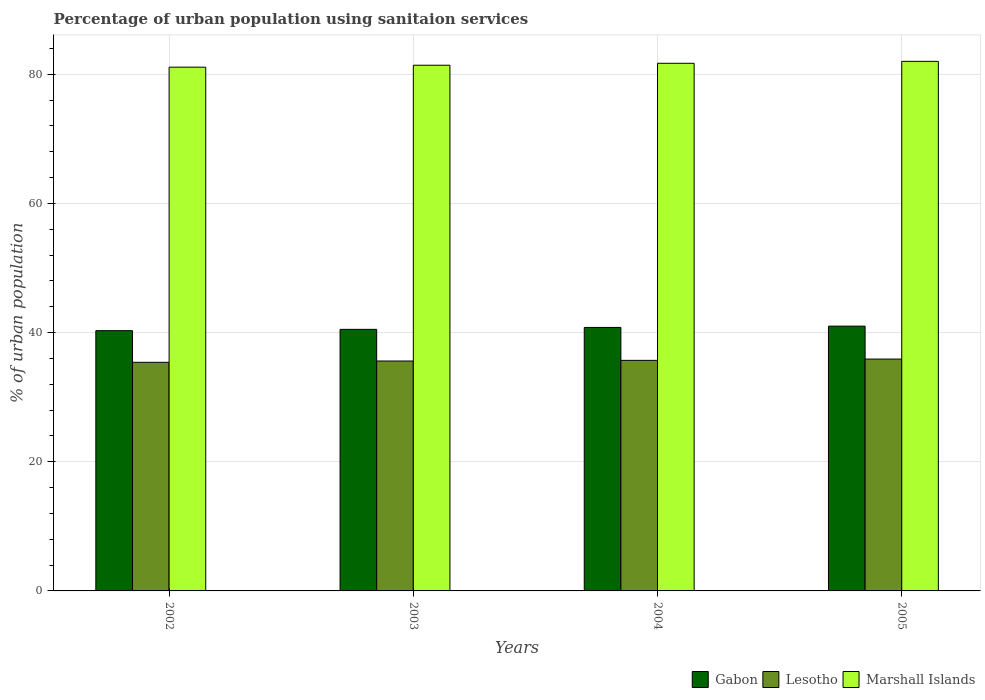How many different coloured bars are there?
Provide a short and direct response. 3. How many groups of bars are there?
Keep it short and to the point. 4. Are the number of bars per tick equal to the number of legend labels?
Your answer should be compact. Yes. Are the number of bars on each tick of the X-axis equal?
Provide a succinct answer. Yes. How many bars are there on the 4th tick from the left?
Ensure brevity in your answer.  3. What is the label of the 1st group of bars from the left?
Your response must be concise. 2002. In how many cases, is the number of bars for a given year not equal to the number of legend labels?
Your response must be concise. 0. What is the percentage of urban population using sanitaion services in Lesotho in 2005?
Make the answer very short. 35.9. Across all years, what is the maximum percentage of urban population using sanitaion services in Lesotho?
Provide a succinct answer. 35.9. Across all years, what is the minimum percentage of urban population using sanitaion services in Gabon?
Give a very brief answer. 40.3. In which year was the percentage of urban population using sanitaion services in Gabon maximum?
Keep it short and to the point. 2005. In which year was the percentage of urban population using sanitaion services in Gabon minimum?
Your response must be concise. 2002. What is the total percentage of urban population using sanitaion services in Gabon in the graph?
Give a very brief answer. 162.6. What is the difference between the percentage of urban population using sanitaion services in Lesotho in 2003 and that in 2004?
Your response must be concise. -0.1. What is the difference between the percentage of urban population using sanitaion services in Gabon in 2005 and the percentage of urban population using sanitaion services in Lesotho in 2003?
Provide a short and direct response. 5.4. What is the average percentage of urban population using sanitaion services in Marshall Islands per year?
Your response must be concise. 81.55. In the year 2002, what is the difference between the percentage of urban population using sanitaion services in Marshall Islands and percentage of urban population using sanitaion services in Lesotho?
Offer a terse response. 45.7. What is the ratio of the percentage of urban population using sanitaion services in Gabon in 2002 to that in 2005?
Make the answer very short. 0.98. Is the percentage of urban population using sanitaion services in Marshall Islands in 2002 less than that in 2004?
Provide a short and direct response. Yes. Is the difference between the percentage of urban population using sanitaion services in Marshall Islands in 2003 and 2005 greater than the difference between the percentage of urban population using sanitaion services in Lesotho in 2003 and 2005?
Provide a succinct answer. No. What is the difference between the highest and the second highest percentage of urban population using sanitaion services in Marshall Islands?
Give a very brief answer. 0.3. Is the sum of the percentage of urban population using sanitaion services in Gabon in 2003 and 2004 greater than the maximum percentage of urban population using sanitaion services in Marshall Islands across all years?
Make the answer very short. No. What does the 1st bar from the left in 2002 represents?
Give a very brief answer. Gabon. What does the 2nd bar from the right in 2005 represents?
Offer a very short reply. Lesotho. Is it the case that in every year, the sum of the percentage of urban population using sanitaion services in Marshall Islands and percentage of urban population using sanitaion services in Gabon is greater than the percentage of urban population using sanitaion services in Lesotho?
Make the answer very short. Yes. How many bars are there?
Offer a terse response. 12. Are all the bars in the graph horizontal?
Give a very brief answer. No. What is the difference between two consecutive major ticks on the Y-axis?
Make the answer very short. 20. Are the values on the major ticks of Y-axis written in scientific E-notation?
Offer a terse response. No. How many legend labels are there?
Your answer should be very brief. 3. What is the title of the graph?
Offer a terse response. Percentage of urban population using sanitaion services. Does "Swaziland" appear as one of the legend labels in the graph?
Offer a very short reply. No. What is the label or title of the Y-axis?
Your answer should be compact. % of urban population. What is the % of urban population in Gabon in 2002?
Offer a very short reply. 40.3. What is the % of urban population of Lesotho in 2002?
Your response must be concise. 35.4. What is the % of urban population of Marshall Islands in 2002?
Ensure brevity in your answer.  81.1. What is the % of urban population in Gabon in 2003?
Make the answer very short. 40.5. What is the % of urban population in Lesotho in 2003?
Offer a very short reply. 35.6. What is the % of urban population in Marshall Islands in 2003?
Provide a succinct answer. 81.4. What is the % of urban population of Gabon in 2004?
Keep it short and to the point. 40.8. What is the % of urban population in Lesotho in 2004?
Provide a short and direct response. 35.7. What is the % of urban population in Marshall Islands in 2004?
Offer a terse response. 81.7. What is the % of urban population of Lesotho in 2005?
Provide a short and direct response. 35.9. What is the % of urban population of Marshall Islands in 2005?
Your answer should be compact. 82. Across all years, what is the maximum % of urban population of Gabon?
Ensure brevity in your answer.  41. Across all years, what is the maximum % of urban population in Lesotho?
Offer a terse response. 35.9. Across all years, what is the maximum % of urban population of Marshall Islands?
Give a very brief answer. 82. Across all years, what is the minimum % of urban population in Gabon?
Give a very brief answer. 40.3. Across all years, what is the minimum % of urban population of Lesotho?
Ensure brevity in your answer.  35.4. Across all years, what is the minimum % of urban population in Marshall Islands?
Give a very brief answer. 81.1. What is the total % of urban population in Gabon in the graph?
Ensure brevity in your answer.  162.6. What is the total % of urban population in Lesotho in the graph?
Your response must be concise. 142.6. What is the total % of urban population in Marshall Islands in the graph?
Give a very brief answer. 326.2. What is the difference between the % of urban population of Lesotho in 2002 and that in 2003?
Your answer should be very brief. -0.2. What is the difference between the % of urban population of Marshall Islands in 2002 and that in 2003?
Offer a very short reply. -0.3. What is the difference between the % of urban population in Gabon in 2002 and that in 2004?
Give a very brief answer. -0.5. What is the difference between the % of urban population in Lesotho in 2002 and that in 2004?
Your answer should be compact. -0.3. What is the difference between the % of urban population in Marshall Islands in 2002 and that in 2005?
Offer a very short reply. -0.9. What is the difference between the % of urban population of Lesotho in 2003 and that in 2004?
Offer a terse response. -0.1. What is the difference between the % of urban population of Marshall Islands in 2003 and that in 2005?
Make the answer very short. -0.6. What is the difference between the % of urban population of Marshall Islands in 2004 and that in 2005?
Keep it short and to the point. -0.3. What is the difference between the % of urban population in Gabon in 2002 and the % of urban population in Lesotho in 2003?
Provide a short and direct response. 4.7. What is the difference between the % of urban population of Gabon in 2002 and the % of urban population of Marshall Islands in 2003?
Offer a terse response. -41.1. What is the difference between the % of urban population in Lesotho in 2002 and the % of urban population in Marshall Islands in 2003?
Your answer should be compact. -46. What is the difference between the % of urban population in Gabon in 2002 and the % of urban population in Lesotho in 2004?
Keep it short and to the point. 4.6. What is the difference between the % of urban population of Gabon in 2002 and the % of urban population of Marshall Islands in 2004?
Your response must be concise. -41.4. What is the difference between the % of urban population of Lesotho in 2002 and the % of urban population of Marshall Islands in 2004?
Make the answer very short. -46.3. What is the difference between the % of urban population of Gabon in 2002 and the % of urban population of Marshall Islands in 2005?
Your answer should be very brief. -41.7. What is the difference between the % of urban population in Lesotho in 2002 and the % of urban population in Marshall Islands in 2005?
Offer a very short reply. -46.6. What is the difference between the % of urban population in Gabon in 2003 and the % of urban population in Marshall Islands in 2004?
Offer a very short reply. -41.2. What is the difference between the % of urban population in Lesotho in 2003 and the % of urban population in Marshall Islands in 2004?
Provide a succinct answer. -46.1. What is the difference between the % of urban population in Gabon in 2003 and the % of urban population in Lesotho in 2005?
Offer a very short reply. 4.6. What is the difference between the % of urban population of Gabon in 2003 and the % of urban population of Marshall Islands in 2005?
Provide a succinct answer. -41.5. What is the difference between the % of urban population in Lesotho in 2003 and the % of urban population in Marshall Islands in 2005?
Offer a terse response. -46.4. What is the difference between the % of urban population in Gabon in 2004 and the % of urban population in Marshall Islands in 2005?
Provide a succinct answer. -41.2. What is the difference between the % of urban population of Lesotho in 2004 and the % of urban population of Marshall Islands in 2005?
Offer a terse response. -46.3. What is the average % of urban population in Gabon per year?
Give a very brief answer. 40.65. What is the average % of urban population in Lesotho per year?
Give a very brief answer. 35.65. What is the average % of urban population of Marshall Islands per year?
Ensure brevity in your answer.  81.55. In the year 2002, what is the difference between the % of urban population of Gabon and % of urban population of Marshall Islands?
Provide a succinct answer. -40.8. In the year 2002, what is the difference between the % of urban population in Lesotho and % of urban population in Marshall Islands?
Provide a succinct answer. -45.7. In the year 2003, what is the difference between the % of urban population of Gabon and % of urban population of Lesotho?
Provide a short and direct response. 4.9. In the year 2003, what is the difference between the % of urban population in Gabon and % of urban population in Marshall Islands?
Provide a succinct answer. -40.9. In the year 2003, what is the difference between the % of urban population of Lesotho and % of urban population of Marshall Islands?
Provide a succinct answer. -45.8. In the year 2004, what is the difference between the % of urban population in Gabon and % of urban population in Lesotho?
Your answer should be compact. 5.1. In the year 2004, what is the difference between the % of urban population of Gabon and % of urban population of Marshall Islands?
Provide a short and direct response. -40.9. In the year 2004, what is the difference between the % of urban population in Lesotho and % of urban population in Marshall Islands?
Keep it short and to the point. -46. In the year 2005, what is the difference between the % of urban population of Gabon and % of urban population of Marshall Islands?
Your answer should be very brief. -41. In the year 2005, what is the difference between the % of urban population of Lesotho and % of urban population of Marshall Islands?
Provide a short and direct response. -46.1. What is the ratio of the % of urban population of Gabon in 2002 to that in 2003?
Your answer should be compact. 1. What is the ratio of the % of urban population in Lesotho in 2002 to that in 2003?
Offer a very short reply. 0.99. What is the ratio of the % of urban population of Marshall Islands in 2002 to that in 2003?
Offer a very short reply. 1. What is the ratio of the % of urban population of Gabon in 2002 to that in 2005?
Your response must be concise. 0.98. What is the ratio of the % of urban population in Lesotho in 2002 to that in 2005?
Provide a short and direct response. 0.99. What is the ratio of the % of urban population of Lesotho in 2003 to that in 2004?
Offer a terse response. 1. What is the ratio of the % of urban population of Lesotho in 2003 to that in 2005?
Ensure brevity in your answer.  0.99. What is the difference between the highest and the second highest % of urban population in Marshall Islands?
Provide a succinct answer. 0.3. What is the difference between the highest and the lowest % of urban population in Gabon?
Make the answer very short. 0.7. 